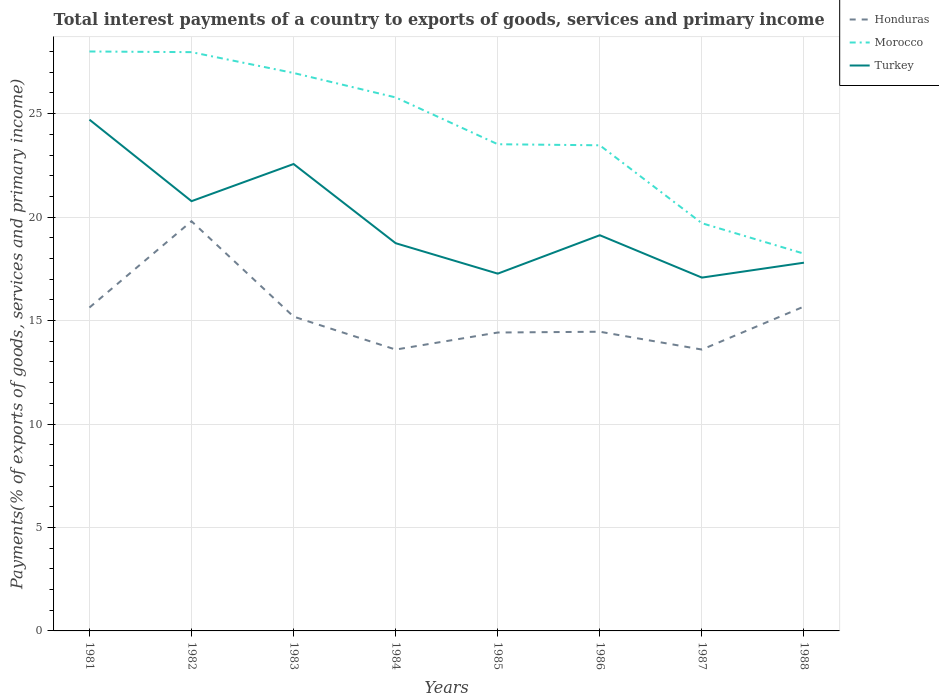How many different coloured lines are there?
Your response must be concise. 3. Does the line corresponding to Morocco intersect with the line corresponding to Honduras?
Your answer should be compact. No. Across all years, what is the maximum total interest payments in Honduras?
Provide a short and direct response. 13.6. What is the total total interest payments in Morocco in the graph?
Your response must be concise. 7.55. What is the difference between the highest and the second highest total interest payments in Turkey?
Make the answer very short. 7.63. How many years are there in the graph?
Your answer should be compact. 8. Does the graph contain grids?
Offer a terse response. Yes. Where does the legend appear in the graph?
Ensure brevity in your answer.  Top right. How many legend labels are there?
Give a very brief answer. 3. What is the title of the graph?
Offer a very short reply. Total interest payments of a country to exports of goods, services and primary income. What is the label or title of the X-axis?
Your response must be concise. Years. What is the label or title of the Y-axis?
Your response must be concise. Payments(% of exports of goods, services and primary income). What is the Payments(% of exports of goods, services and primary income) in Honduras in 1981?
Your answer should be compact. 15.63. What is the Payments(% of exports of goods, services and primary income) in Morocco in 1981?
Offer a terse response. 28. What is the Payments(% of exports of goods, services and primary income) in Turkey in 1981?
Give a very brief answer. 24.71. What is the Payments(% of exports of goods, services and primary income) of Honduras in 1982?
Provide a short and direct response. 19.8. What is the Payments(% of exports of goods, services and primary income) in Morocco in 1982?
Offer a terse response. 27.97. What is the Payments(% of exports of goods, services and primary income) in Turkey in 1982?
Keep it short and to the point. 20.77. What is the Payments(% of exports of goods, services and primary income) of Honduras in 1983?
Ensure brevity in your answer.  15.19. What is the Payments(% of exports of goods, services and primary income) of Morocco in 1983?
Your answer should be compact. 26.96. What is the Payments(% of exports of goods, services and primary income) in Turkey in 1983?
Your answer should be compact. 22.56. What is the Payments(% of exports of goods, services and primary income) in Honduras in 1984?
Provide a succinct answer. 13.6. What is the Payments(% of exports of goods, services and primary income) of Morocco in 1984?
Ensure brevity in your answer.  25.78. What is the Payments(% of exports of goods, services and primary income) of Turkey in 1984?
Your answer should be very brief. 18.74. What is the Payments(% of exports of goods, services and primary income) in Honduras in 1985?
Ensure brevity in your answer.  14.42. What is the Payments(% of exports of goods, services and primary income) of Morocco in 1985?
Keep it short and to the point. 23.52. What is the Payments(% of exports of goods, services and primary income) in Turkey in 1985?
Your answer should be compact. 17.27. What is the Payments(% of exports of goods, services and primary income) of Honduras in 1986?
Offer a very short reply. 14.46. What is the Payments(% of exports of goods, services and primary income) of Morocco in 1986?
Offer a very short reply. 23.47. What is the Payments(% of exports of goods, services and primary income) of Turkey in 1986?
Your answer should be very brief. 19.12. What is the Payments(% of exports of goods, services and primary income) in Honduras in 1987?
Make the answer very short. 13.6. What is the Payments(% of exports of goods, services and primary income) in Morocco in 1987?
Provide a succinct answer. 19.7. What is the Payments(% of exports of goods, services and primary income) in Turkey in 1987?
Keep it short and to the point. 17.08. What is the Payments(% of exports of goods, services and primary income) of Honduras in 1988?
Make the answer very short. 15.68. What is the Payments(% of exports of goods, services and primary income) of Morocco in 1988?
Make the answer very short. 18.23. What is the Payments(% of exports of goods, services and primary income) in Turkey in 1988?
Your answer should be very brief. 17.8. Across all years, what is the maximum Payments(% of exports of goods, services and primary income) of Honduras?
Ensure brevity in your answer.  19.8. Across all years, what is the maximum Payments(% of exports of goods, services and primary income) of Morocco?
Your answer should be very brief. 28. Across all years, what is the maximum Payments(% of exports of goods, services and primary income) of Turkey?
Your answer should be very brief. 24.71. Across all years, what is the minimum Payments(% of exports of goods, services and primary income) in Honduras?
Provide a succinct answer. 13.6. Across all years, what is the minimum Payments(% of exports of goods, services and primary income) in Morocco?
Your answer should be compact. 18.23. Across all years, what is the minimum Payments(% of exports of goods, services and primary income) in Turkey?
Provide a short and direct response. 17.08. What is the total Payments(% of exports of goods, services and primary income) in Honduras in the graph?
Keep it short and to the point. 122.37. What is the total Payments(% of exports of goods, services and primary income) in Morocco in the graph?
Your response must be concise. 193.65. What is the total Payments(% of exports of goods, services and primary income) in Turkey in the graph?
Offer a terse response. 158.04. What is the difference between the Payments(% of exports of goods, services and primary income) in Honduras in 1981 and that in 1982?
Offer a very short reply. -4.17. What is the difference between the Payments(% of exports of goods, services and primary income) in Morocco in 1981 and that in 1982?
Keep it short and to the point. 0.03. What is the difference between the Payments(% of exports of goods, services and primary income) of Turkey in 1981 and that in 1982?
Offer a very short reply. 3.94. What is the difference between the Payments(% of exports of goods, services and primary income) in Honduras in 1981 and that in 1983?
Offer a terse response. 0.44. What is the difference between the Payments(% of exports of goods, services and primary income) of Morocco in 1981 and that in 1983?
Keep it short and to the point. 1.04. What is the difference between the Payments(% of exports of goods, services and primary income) in Turkey in 1981 and that in 1983?
Give a very brief answer. 2.14. What is the difference between the Payments(% of exports of goods, services and primary income) of Honduras in 1981 and that in 1984?
Give a very brief answer. 2.03. What is the difference between the Payments(% of exports of goods, services and primary income) of Morocco in 1981 and that in 1984?
Offer a very short reply. 2.22. What is the difference between the Payments(% of exports of goods, services and primary income) in Turkey in 1981 and that in 1984?
Provide a succinct answer. 5.97. What is the difference between the Payments(% of exports of goods, services and primary income) of Honduras in 1981 and that in 1985?
Provide a succinct answer. 1.21. What is the difference between the Payments(% of exports of goods, services and primary income) of Morocco in 1981 and that in 1985?
Your answer should be very brief. 4.48. What is the difference between the Payments(% of exports of goods, services and primary income) of Turkey in 1981 and that in 1985?
Ensure brevity in your answer.  7.44. What is the difference between the Payments(% of exports of goods, services and primary income) of Honduras in 1981 and that in 1986?
Your response must be concise. 1.17. What is the difference between the Payments(% of exports of goods, services and primary income) in Morocco in 1981 and that in 1986?
Your response must be concise. 4.53. What is the difference between the Payments(% of exports of goods, services and primary income) in Turkey in 1981 and that in 1986?
Offer a terse response. 5.59. What is the difference between the Payments(% of exports of goods, services and primary income) in Honduras in 1981 and that in 1987?
Your answer should be very brief. 2.03. What is the difference between the Payments(% of exports of goods, services and primary income) of Morocco in 1981 and that in 1987?
Provide a short and direct response. 8.3. What is the difference between the Payments(% of exports of goods, services and primary income) in Turkey in 1981 and that in 1987?
Provide a short and direct response. 7.63. What is the difference between the Payments(% of exports of goods, services and primary income) of Honduras in 1981 and that in 1988?
Offer a very short reply. -0.05. What is the difference between the Payments(% of exports of goods, services and primary income) of Morocco in 1981 and that in 1988?
Give a very brief answer. 9.77. What is the difference between the Payments(% of exports of goods, services and primary income) in Turkey in 1981 and that in 1988?
Your response must be concise. 6.91. What is the difference between the Payments(% of exports of goods, services and primary income) in Honduras in 1982 and that in 1983?
Provide a succinct answer. 4.61. What is the difference between the Payments(% of exports of goods, services and primary income) of Morocco in 1982 and that in 1983?
Offer a terse response. 1.01. What is the difference between the Payments(% of exports of goods, services and primary income) of Turkey in 1982 and that in 1983?
Offer a terse response. -1.8. What is the difference between the Payments(% of exports of goods, services and primary income) in Honduras in 1982 and that in 1984?
Ensure brevity in your answer.  6.2. What is the difference between the Payments(% of exports of goods, services and primary income) of Morocco in 1982 and that in 1984?
Your answer should be very brief. 2.19. What is the difference between the Payments(% of exports of goods, services and primary income) in Turkey in 1982 and that in 1984?
Ensure brevity in your answer.  2.03. What is the difference between the Payments(% of exports of goods, services and primary income) of Honduras in 1982 and that in 1985?
Your answer should be very brief. 5.38. What is the difference between the Payments(% of exports of goods, services and primary income) in Morocco in 1982 and that in 1985?
Offer a terse response. 4.45. What is the difference between the Payments(% of exports of goods, services and primary income) of Turkey in 1982 and that in 1985?
Offer a terse response. 3.5. What is the difference between the Payments(% of exports of goods, services and primary income) of Honduras in 1982 and that in 1986?
Your answer should be compact. 5.34. What is the difference between the Payments(% of exports of goods, services and primary income) in Morocco in 1982 and that in 1986?
Your answer should be compact. 4.5. What is the difference between the Payments(% of exports of goods, services and primary income) of Turkey in 1982 and that in 1986?
Give a very brief answer. 1.65. What is the difference between the Payments(% of exports of goods, services and primary income) of Honduras in 1982 and that in 1987?
Offer a very short reply. 6.2. What is the difference between the Payments(% of exports of goods, services and primary income) of Morocco in 1982 and that in 1987?
Provide a short and direct response. 8.27. What is the difference between the Payments(% of exports of goods, services and primary income) of Turkey in 1982 and that in 1987?
Your answer should be compact. 3.69. What is the difference between the Payments(% of exports of goods, services and primary income) of Honduras in 1982 and that in 1988?
Your response must be concise. 4.12. What is the difference between the Payments(% of exports of goods, services and primary income) of Morocco in 1982 and that in 1988?
Your answer should be compact. 9.74. What is the difference between the Payments(% of exports of goods, services and primary income) in Turkey in 1982 and that in 1988?
Your answer should be compact. 2.97. What is the difference between the Payments(% of exports of goods, services and primary income) in Honduras in 1983 and that in 1984?
Offer a very short reply. 1.59. What is the difference between the Payments(% of exports of goods, services and primary income) in Morocco in 1983 and that in 1984?
Provide a succinct answer. 1.18. What is the difference between the Payments(% of exports of goods, services and primary income) in Turkey in 1983 and that in 1984?
Provide a short and direct response. 3.83. What is the difference between the Payments(% of exports of goods, services and primary income) in Honduras in 1983 and that in 1985?
Your answer should be very brief. 0.77. What is the difference between the Payments(% of exports of goods, services and primary income) in Morocco in 1983 and that in 1985?
Your answer should be compact. 3.44. What is the difference between the Payments(% of exports of goods, services and primary income) in Turkey in 1983 and that in 1985?
Provide a short and direct response. 5.3. What is the difference between the Payments(% of exports of goods, services and primary income) in Honduras in 1983 and that in 1986?
Provide a succinct answer. 0.73. What is the difference between the Payments(% of exports of goods, services and primary income) of Morocco in 1983 and that in 1986?
Your response must be concise. 3.49. What is the difference between the Payments(% of exports of goods, services and primary income) of Turkey in 1983 and that in 1986?
Keep it short and to the point. 3.44. What is the difference between the Payments(% of exports of goods, services and primary income) in Honduras in 1983 and that in 1987?
Offer a terse response. 1.59. What is the difference between the Payments(% of exports of goods, services and primary income) in Morocco in 1983 and that in 1987?
Your answer should be compact. 7.26. What is the difference between the Payments(% of exports of goods, services and primary income) in Turkey in 1983 and that in 1987?
Provide a short and direct response. 5.49. What is the difference between the Payments(% of exports of goods, services and primary income) in Honduras in 1983 and that in 1988?
Keep it short and to the point. -0.49. What is the difference between the Payments(% of exports of goods, services and primary income) of Morocco in 1983 and that in 1988?
Make the answer very short. 8.73. What is the difference between the Payments(% of exports of goods, services and primary income) in Turkey in 1983 and that in 1988?
Provide a succinct answer. 4.77. What is the difference between the Payments(% of exports of goods, services and primary income) in Honduras in 1984 and that in 1985?
Your answer should be very brief. -0.82. What is the difference between the Payments(% of exports of goods, services and primary income) in Morocco in 1984 and that in 1985?
Provide a short and direct response. 2.26. What is the difference between the Payments(% of exports of goods, services and primary income) of Turkey in 1984 and that in 1985?
Your response must be concise. 1.47. What is the difference between the Payments(% of exports of goods, services and primary income) in Honduras in 1984 and that in 1986?
Ensure brevity in your answer.  -0.86. What is the difference between the Payments(% of exports of goods, services and primary income) in Morocco in 1984 and that in 1986?
Your answer should be very brief. 2.31. What is the difference between the Payments(% of exports of goods, services and primary income) in Turkey in 1984 and that in 1986?
Give a very brief answer. -0.39. What is the difference between the Payments(% of exports of goods, services and primary income) of Honduras in 1984 and that in 1987?
Your answer should be very brief. -0. What is the difference between the Payments(% of exports of goods, services and primary income) of Morocco in 1984 and that in 1987?
Offer a terse response. 6.08. What is the difference between the Payments(% of exports of goods, services and primary income) in Turkey in 1984 and that in 1987?
Offer a very short reply. 1.66. What is the difference between the Payments(% of exports of goods, services and primary income) in Honduras in 1984 and that in 1988?
Offer a terse response. -2.08. What is the difference between the Payments(% of exports of goods, services and primary income) of Morocco in 1984 and that in 1988?
Your response must be concise. 7.55. What is the difference between the Payments(% of exports of goods, services and primary income) in Turkey in 1984 and that in 1988?
Offer a very short reply. 0.94. What is the difference between the Payments(% of exports of goods, services and primary income) in Honduras in 1985 and that in 1986?
Give a very brief answer. -0.04. What is the difference between the Payments(% of exports of goods, services and primary income) of Morocco in 1985 and that in 1986?
Make the answer very short. 0.05. What is the difference between the Payments(% of exports of goods, services and primary income) in Turkey in 1985 and that in 1986?
Make the answer very short. -1.86. What is the difference between the Payments(% of exports of goods, services and primary income) in Honduras in 1985 and that in 1987?
Ensure brevity in your answer.  0.82. What is the difference between the Payments(% of exports of goods, services and primary income) of Morocco in 1985 and that in 1987?
Your response must be concise. 3.82. What is the difference between the Payments(% of exports of goods, services and primary income) of Turkey in 1985 and that in 1987?
Make the answer very short. 0.19. What is the difference between the Payments(% of exports of goods, services and primary income) in Honduras in 1985 and that in 1988?
Provide a succinct answer. -1.26. What is the difference between the Payments(% of exports of goods, services and primary income) in Morocco in 1985 and that in 1988?
Provide a succinct answer. 5.29. What is the difference between the Payments(% of exports of goods, services and primary income) in Turkey in 1985 and that in 1988?
Provide a succinct answer. -0.53. What is the difference between the Payments(% of exports of goods, services and primary income) in Honduras in 1986 and that in 1987?
Your answer should be very brief. 0.86. What is the difference between the Payments(% of exports of goods, services and primary income) of Morocco in 1986 and that in 1987?
Your response must be concise. 3.77. What is the difference between the Payments(% of exports of goods, services and primary income) in Turkey in 1986 and that in 1987?
Your answer should be very brief. 2.05. What is the difference between the Payments(% of exports of goods, services and primary income) of Honduras in 1986 and that in 1988?
Your response must be concise. -1.22. What is the difference between the Payments(% of exports of goods, services and primary income) of Morocco in 1986 and that in 1988?
Provide a succinct answer. 5.24. What is the difference between the Payments(% of exports of goods, services and primary income) in Turkey in 1986 and that in 1988?
Keep it short and to the point. 1.33. What is the difference between the Payments(% of exports of goods, services and primary income) in Honduras in 1987 and that in 1988?
Offer a terse response. -2.08. What is the difference between the Payments(% of exports of goods, services and primary income) in Morocco in 1987 and that in 1988?
Your response must be concise. 1.47. What is the difference between the Payments(% of exports of goods, services and primary income) of Turkey in 1987 and that in 1988?
Keep it short and to the point. -0.72. What is the difference between the Payments(% of exports of goods, services and primary income) of Honduras in 1981 and the Payments(% of exports of goods, services and primary income) of Morocco in 1982?
Provide a succinct answer. -12.34. What is the difference between the Payments(% of exports of goods, services and primary income) of Honduras in 1981 and the Payments(% of exports of goods, services and primary income) of Turkey in 1982?
Your answer should be compact. -5.14. What is the difference between the Payments(% of exports of goods, services and primary income) of Morocco in 1981 and the Payments(% of exports of goods, services and primary income) of Turkey in 1982?
Offer a terse response. 7.23. What is the difference between the Payments(% of exports of goods, services and primary income) in Honduras in 1981 and the Payments(% of exports of goods, services and primary income) in Morocco in 1983?
Your response must be concise. -11.34. What is the difference between the Payments(% of exports of goods, services and primary income) of Honduras in 1981 and the Payments(% of exports of goods, services and primary income) of Turkey in 1983?
Keep it short and to the point. -6.94. What is the difference between the Payments(% of exports of goods, services and primary income) in Morocco in 1981 and the Payments(% of exports of goods, services and primary income) in Turkey in 1983?
Provide a short and direct response. 5.44. What is the difference between the Payments(% of exports of goods, services and primary income) of Honduras in 1981 and the Payments(% of exports of goods, services and primary income) of Morocco in 1984?
Keep it short and to the point. -10.15. What is the difference between the Payments(% of exports of goods, services and primary income) of Honduras in 1981 and the Payments(% of exports of goods, services and primary income) of Turkey in 1984?
Offer a very short reply. -3.11. What is the difference between the Payments(% of exports of goods, services and primary income) in Morocco in 1981 and the Payments(% of exports of goods, services and primary income) in Turkey in 1984?
Offer a terse response. 9.27. What is the difference between the Payments(% of exports of goods, services and primary income) in Honduras in 1981 and the Payments(% of exports of goods, services and primary income) in Morocco in 1985?
Make the answer very short. -7.89. What is the difference between the Payments(% of exports of goods, services and primary income) of Honduras in 1981 and the Payments(% of exports of goods, services and primary income) of Turkey in 1985?
Your answer should be compact. -1.64. What is the difference between the Payments(% of exports of goods, services and primary income) of Morocco in 1981 and the Payments(% of exports of goods, services and primary income) of Turkey in 1985?
Provide a short and direct response. 10.74. What is the difference between the Payments(% of exports of goods, services and primary income) in Honduras in 1981 and the Payments(% of exports of goods, services and primary income) in Morocco in 1986?
Provide a short and direct response. -7.84. What is the difference between the Payments(% of exports of goods, services and primary income) in Honduras in 1981 and the Payments(% of exports of goods, services and primary income) in Turkey in 1986?
Ensure brevity in your answer.  -3.5. What is the difference between the Payments(% of exports of goods, services and primary income) of Morocco in 1981 and the Payments(% of exports of goods, services and primary income) of Turkey in 1986?
Make the answer very short. 8.88. What is the difference between the Payments(% of exports of goods, services and primary income) in Honduras in 1981 and the Payments(% of exports of goods, services and primary income) in Morocco in 1987?
Your answer should be very brief. -4.08. What is the difference between the Payments(% of exports of goods, services and primary income) in Honduras in 1981 and the Payments(% of exports of goods, services and primary income) in Turkey in 1987?
Offer a terse response. -1.45. What is the difference between the Payments(% of exports of goods, services and primary income) in Morocco in 1981 and the Payments(% of exports of goods, services and primary income) in Turkey in 1987?
Your answer should be very brief. 10.93. What is the difference between the Payments(% of exports of goods, services and primary income) of Honduras in 1981 and the Payments(% of exports of goods, services and primary income) of Morocco in 1988?
Your answer should be compact. -2.6. What is the difference between the Payments(% of exports of goods, services and primary income) in Honduras in 1981 and the Payments(% of exports of goods, services and primary income) in Turkey in 1988?
Keep it short and to the point. -2.17. What is the difference between the Payments(% of exports of goods, services and primary income) in Morocco in 1981 and the Payments(% of exports of goods, services and primary income) in Turkey in 1988?
Your answer should be compact. 10.21. What is the difference between the Payments(% of exports of goods, services and primary income) of Honduras in 1982 and the Payments(% of exports of goods, services and primary income) of Morocco in 1983?
Provide a short and direct response. -7.16. What is the difference between the Payments(% of exports of goods, services and primary income) of Honduras in 1982 and the Payments(% of exports of goods, services and primary income) of Turkey in 1983?
Your answer should be compact. -2.77. What is the difference between the Payments(% of exports of goods, services and primary income) of Morocco in 1982 and the Payments(% of exports of goods, services and primary income) of Turkey in 1983?
Give a very brief answer. 5.41. What is the difference between the Payments(% of exports of goods, services and primary income) in Honduras in 1982 and the Payments(% of exports of goods, services and primary income) in Morocco in 1984?
Keep it short and to the point. -5.98. What is the difference between the Payments(% of exports of goods, services and primary income) of Honduras in 1982 and the Payments(% of exports of goods, services and primary income) of Turkey in 1984?
Your answer should be compact. 1.06. What is the difference between the Payments(% of exports of goods, services and primary income) of Morocco in 1982 and the Payments(% of exports of goods, services and primary income) of Turkey in 1984?
Make the answer very short. 9.23. What is the difference between the Payments(% of exports of goods, services and primary income) in Honduras in 1982 and the Payments(% of exports of goods, services and primary income) in Morocco in 1985?
Offer a very short reply. -3.72. What is the difference between the Payments(% of exports of goods, services and primary income) of Honduras in 1982 and the Payments(% of exports of goods, services and primary income) of Turkey in 1985?
Keep it short and to the point. 2.53. What is the difference between the Payments(% of exports of goods, services and primary income) of Morocco in 1982 and the Payments(% of exports of goods, services and primary income) of Turkey in 1985?
Give a very brief answer. 10.7. What is the difference between the Payments(% of exports of goods, services and primary income) of Honduras in 1982 and the Payments(% of exports of goods, services and primary income) of Morocco in 1986?
Give a very brief answer. -3.67. What is the difference between the Payments(% of exports of goods, services and primary income) of Honduras in 1982 and the Payments(% of exports of goods, services and primary income) of Turkey in 1986?
Provide a short and direct response. 0.68. What is the difference between the Payments(% of exports of goods, services and primary income) of Morocco in 1982 and the Payments(% of exports of goods, services and primary income) of Turkey in 1986?
Keep it short and to the point. 8.85. What is the difference between the Payments(% of exports of goods, services and primary income) in Honduras in 1982 and the Payments(% of exports of goods, services and primary income) in Morocco in 1987?
Your answer should be very brief. 0.1. What is the difference between the Payments(% of exports of goods, services and primary income) of Honduras in 1982 and the Payments(% of exports of goods, services and primary income) of Turkey in 1987?
Offer a terse response. 2.72. What is the difference between the Payments(% of exports of goods, services and primary income) in Morocco in 1982 and the Payments(% of exports of goods, services and primary income) in Turkey in 1987?
Your answer should be very brief. 10.9. What is the difference between the Payments(% of exports of goods, services and primary income) in Honduras in 1982 and the Payments(% of exports of goods, services and primary income) in Morocco in 1988?
Your response must be concise. 1.57. What is the difference between the Payments(% of exports of goods, services and primary income) in Honduras in 1982 and the Payments(% of exports of goods, services and primary income) in Turkey in 1988?
Your response must be concise. 2. What is the difference between the Payments(% of exports of goods, services and primary income) of Morocco in 1982 and the Payments(% of exports of goods, services and primary income) of Turkey in 1988?
Ensure brevity in your answer.  10.18. What is the difference between the Payments(% of exports of goods, services and primary income) in Honduras in 1983 and the Payments(% of exports of goods, services and primary income) in Morocco in 1984?
Provide a succinct answer. -10.59. What is the difference between the Payments(% of exports of goods, services and primary income) of Honduras in 1983 and the Payments(% of exports of goods, services and primary income) of Turkey in 1984?
Your answer should be very brief. -3.55. What is the difference between the Payments(% of exports of goods, services and primary income) in Morocco in 1983 and the Payments(% of exports of goods, services and primary income) in Turkey in 1984?
Provide a short and direct response. 8.23. What is the difference between the Payments(% of exports of goods, services and primary income) of Honduras in 1983 and the Payments(% of exports of goods, services and primary income) of Morocco in 1985?
Make the answer very short. -8.33. What is the difference between the Payments(% of exports of goods, services and primary income) of Honduras in 1983 and the Payments(% of exports of goods, services and primary income) of Turkey in 1985?
Make the answer very short. -2.08. What is the difference between the Payments(% of exports of goods, services and primary income) of Morocco in 1983 and the Payments(% of exports of goods, services and primary income) of Turkey in 1985?
Provide a succinct answer. 9.7. What is the difference between the Payments(% of exports of goods, services and primary income) in Honduras in 1983 and the Payments(% of exports of goods, services and primary income) in Morocco in 1986?
Provide a short and direct response. -8.28. What is the difference between the Payments(% of exports of goods, services and primary income) of Honduras in 1983 and the Payments(% of exports of goods, services and primary income) of Turkey in 1986?
Offer a very short reply. -3.93. What is the difference between the Payments(% of exports of goods, services and primary income) of Morocco in 1983 and the Payments(% of exports of goods, services and primary income) of Turkey in 1986?
Provide a short and direct response. 7.84. What is the difference between the Payments(% of exports of goods, services and primary income) of Honduras in 1983 and the Payments(% of exports of goods, services and primary income) of Morocco in 1987?
Keep it short and to the point. -4.51. What is the difference between the Payments(% of exports of goods, services and primary income) of Honduras in 1983 and the Payments(% of exports of goods, services and primary income) of Turkey in 1987?
Give a very brief answer. -1.89. What is the difference between the Payments(% of exports of goods, services and primary income) of Morocco in 1983 and the Payments(% of exports of goods, services and primary income) of Turkey in 1987?
Provide a succinct answer. 9.89. What is the difference between the Payments(% of exports of goods, services and primary income) in Honduras in 1983 and the Payments(% of exports of goods, services and primary income) in Morocco in 1988?
Keep it short and to the point. -3.04. What is the difference between the Payments(% of exports of goods, services and primary income) of Honduras in 1983 and the Payments(% of exports of goods, services and primary income) of Turkey in 1988?
Make the answer very short. -2.61. What is the difference between the Payments(% of exports of goods, services and primary income) in Morocco in 1983 and the Payments(% of exports of goods, services and primary income) in Turkey in 1988?
Offer a terse response. 9.17. What is the difference between the Payments(% of exports of goods, services and primary income) in Honduras in 1984 and the Payments(% of exports of goods, services and primary income) in Morocco in 1985?
Provide a short and direct response. -9.92. What is the difference between the Payments(% of exports of goods, services and primary income) of Honduras in 1984 and the Payments(% of exports of goods, services and primary income) of Turkey in 1985?
Keep it short and to the point. -3.67. What is the difference between the Payments(% of exports of goods, services and primary income) of Morocco in 1984 and the Payments(% of exports of goods, services and primary income) of Turkey in 1985?
Make the answer very short. 8.52. What is the difference between the Payments(% of exports of goods, services and primary income) in Honduras in 1984 and the Payments(% of exports of goods, services and primary income) in Morocco in 1986?
Keep it short and to the point. -9.87. What is the difference between the Payments(% of exports of goods, services and primary income) of Honduras in 1984 and the Payments(% of exports of goods, services and primary income) of Turkey in 1986?
Keep it short and to the point. -5.53. What is the difference between the Payments(% of exports of goods, services and primary income) in Morocco in 1984 and the Payments(% of exports of goods, services and primary income) in Turkey in 1986?
Make the answer very short. 6.66. What is the difference between the Payments(% of exports of goods, services and primary income) of Honduras in 1984 and the Payments(% of exports of goods, services and primary income) of Morocco in 1987?
Your answer should be very brief. -6.11. What is the difference between the Payments(% of exports of goods, services and primary income) of Honduras in 1984 and the Payments(% of exports of goods, services and primary income) of Turkey in 1987?
Offer a terse response. -3.48. What is the difference between the Payments(% of exports of goods, services and primary income) in Morocco in 1984 and the Payments(% of exports of goods, services and primary income) in Turkey in 1987?
Give a very brief answer. 8.71. What is the difference between the Payments(% of exports of goods, services and primary income) in Honduras in 1984 and the Payments(% of exports of goods, services and primary income) in Morocco in 1988?
Keep it short and to the point. -4.63. What is the difference between the Payments(% of exports of goods, services and primary income) of Honduras in 1984 and the Payments(% of exports of goods, services and primary income) of Turkey in 1988?
Ensure brevity in your answer.  -4.2. What is the difference between the Payments(% of exports of goods, services and primary income) of Morocco in 1984 and the Payments(% of exports of goods, services and primary income) of Turkey in 1988?
Offer a very short reply. 7.99. What is the difference between the Payments(% of exports of goods, services and primary income) in Honduras in 1985 and the Payments(% of exports of goods, services and primary income) in Morocco in 1986?
Your response must be concise. -9.05. What is the difference between the Payments(% of exports of goods, services and primary income) in Honduras in 1985 and the Payments(% of exports of goods, services and primary income) in Turkey in 1986?
Provide a short and direct response. -4.7. What is the difference between the Payments(% of exports of goods, services and primary income) of Morocco in 1985 and the Payments(% of exports of goods, services and primary income) of Turkey in 1986?
Give a very brief answer. 4.4. What is the difference between the Payments(% of exports of goods, services and primary income) in Honduras in 1985 and the Payments(% of exports of goods, services and primary income) in Morocco in 1987?
Your answer should be very brief. -5.28. What is the difference between the Payments(% of exports of goods, services and primary income) in Honduras in 1985 and the Payments(% of exports of goods, services and primary income) in Turkey in 1987?
Give a very brief answer. -2.65. What is the difference between the Payments(% of exports of goods, services and primary income) in Morocco in 1985 and the Payments(% of exports of goods, services and primary income) in Turkey in 1987?
Your answer should be compact. 6.45. What is the difference between the Payments(% of exports of goods, services and primary income) in Honduras in 1985 and the Payments(% of exports of goods, services and primary income) in Morocco in 1988?
Make the answer very short. -3.81. What is the difference between the Payments(% of exports of goods, services and primary income) of Honduras in 1985 and the Payments(% of exports of goods, services and primary income) of Turkey in 1988?
Provide a succinct answer. -3.37. What is the difference between the Payments(% of exports of goods, services and primary income) of Morocco in 1985 and the Payments(% of exports of goods, services and primary income) of Turkey in 1988?
Offer a terse response. 5.72. What is the difference between the Payments(% of exports of goods, services and primary income) of Honduras in 1986 and the Payments(% of exports of goods, services and primary income) of Morocco in 1987?
Keep it short and to the point. -5.24. What is the difference between the Payments(% of exports of goods, services and primary income) of Honduras in 1986 and the Payments(% of exports of goods, services and primary income) of Turkey in 1987?
Offer a very short reply. -2.62. What is the difference between the Payments(% of exports of goods, services and primary income) in Morocco in 1986 and the Payments(% of exports of goods, services and primary income) in Turkey in 1987?
Provide a short and direct response. 6.39. What is the difference between the Payments(% of exports of goods, services and primary income) of Honduras in 1986 and the Payments(% of exports of goods, services and primary income) of Morocco in 1988?
Ensure brevity in your answer.  -3.77. What is the difference between the Payments(% of exports of goods, services and primary income) in Honduras in 1986 and the Payments(% of exports of goods, services and primary income) in Turkey in 1988?
Ensure brevity in your answer.  -3.34. What is the difference between the Payments(% of exports of goods, services and primary income) in Morocco in 1986 and the Payments(% of exports of goods, services and primary income) in Turkey in 1988?
Make the answer very short. 5.67. What is the difference between the Payments(% of exports of goods, services and primary income) in Honduras in 1987 and the Payments(% of exports of goods, services and primary income) in Morocco in 1988?
Provide a succinct answer. -4.63. What is the difference between the Payments(% of exports of goods, services and primary income) of Honduras in 1987 and the Payments(% of exports of goods, services and primary income) of Turkey in 1988?
Your answer should be very brief. -4.2. What is the difference between the Payments(% of exports of goods, services and primary income) of Morocco in 1987 and the Payments(% of exports of goods, services and primary income) of Turkey in 1988?
Ensure brevity in your answer.  1.91. What is the average Payments(% of exports of goods, services and primary income) of Honduras per year?
Ensure brevity in your answer.  15.3. What is the average Payments(% of exports of goods, services and primary income) in Morocco per year?
Keep it short and to the point. 24.21. What is the average Payments(% of exports of goods, services and primary income) in Turkey per year?
Your response must be concise. 19.76. In the year 1981, what is the difference between the Payments(% of exports of goods, services and primary income) of Honduras and Payments(% of exports of goods, services and primary income) of Morocco?
Provide a short and direct response. -12.38. In the year 1981, what is the difference between the Payments(% of exports of goods, services and primary income) of Honduras and Payments(% of exports of goods, services and primary income) of Turkey?
Provide a short and direct response. -9.08. In the year 1981, what is the difference between the Payments(% of exports of goods, services and primary income) of Morocco and Payments(% of exports of goods, services and primary income) of Turkey?
Offer a very short reply. 3.29. In the year 1982, what is the difference between the Payments(% of exports of goods, services and primary income) of Honduras and Payments(% of exports of goods, services and primary income) of Morocco?
Offer a very short reply. -8.17. In the year 1982, what is the difference between the Payments(% of exports of goods, services and primary income) in Honduras and Payments(% of exports of goods, services and primary income) in Turkey?
Give a very brief answer. -0.97. In the year 1982, what is the difference between the Payments(% of exports of goods, services and primary income) of Morocco and Payments(% of exports of goods, services and primary income) of Turkey?
Your response must be concise. 7.2. In the year 1983, what is the difference between the Payments(% of exports of goods, services and primary income) of Honduras and Payments(% of exports of goods, services and primary income) of Morocco?
Your answer should be compact. -11.77. In the year 1983, what is the difference between the Payments(% of exports of goods, services and primary income) of Honduras and Payments(% of exports of goods, services and primary income) of Turkey?
Provide a succinct answer. -7.38. In the year 1983, what is the difference between the Payments(% of exports of goods, services and primary income) of Morocco and Payments(% of exports of goods, services and primary income) of Turkey?
Provide a short and direct response. 4.4. In the year 1984, what is the difference between the Payments(% of exports of goods, services and primary income) of Honduras and Payments(% of exports of goods, services and primary income) of Morocco?
Your answer should be very brief. -12.19. In the year 1984, what is the difference between the Payments(% of exports of goods, services and primary income) of Honduras and Payments(% of exports of goods, services and primary income) of Turkey?
Your answer should be very brief. -5.14. In the year 1984, what is the difference between the Payments(% of exports of goods, services and primary income) of Morocco and Payments(% of exports of goods, services and primary income) of Turkey?
Provide a succinct answer. 7.05. In the year 1985, what is the difference between the Payments(% of exports of goods, services and primary income) of Honduras and Payments(% of exports of goods, services and primary income) of Morocco?
Your response must be concise. -9.1. In the year 1985, what is the difference between the Payments(% of exports of goods, services and primary income) of Honduras and Payments(% of exports of goods, services and primary income) of Turkey?
Your response must be concise. -2.85. In the year 1985, what is the difference between the Payments(% of exports of goods, services and primary income) of Morocco and Payments(% of exports of goods, services and primary income) of Turkey?
Keep it short and to the point. 6.25. In the year 1986, what is the difference between the Payments(% of exports of goods, services and primary income) in Honduras and Payments(% of exports of goods, services and primary income) in Morocco?
Ensure brevity in your answer.  -9.01. In the year 1986, what is the difference between the Payments(% of exports of goods, services and primary income) in Honduras and Payments(% of exports of goods, services and primary income) in Turkey?
Give a very brief answer. -4.66. In the year 1986, what is the difference between the Payments(% of exports of goods, services and primary income) of Morocco and Payments(% of exports of goods, services and primary income) of Turkey?
Your answer should be very brief. 4.35. In the year 1987, what is the difference between the Payments(% of exports of goods, services and primary income) of Honduras and Payments(% of exports of goods, services and primary income) of Morocco?
Give a very brief answer. -6.11. In the year 1987, what is the difference between the Payments(% of exports of goods, services and primary income) of Honduras and Payments(% of exports of goods, services and primary income) of Turkey?
Provide a succinct answer. -3.48. In the year 1987, what is the difference between the Payments(% of exports of goods, services and primary income) of Morocco and Payments(% of exports of goods, services and primary income) of Turkey?
Give a very brief answer. 2.63. In the year 1988, what is the difference between the Payments(% of exports of goods, services and primary income) of Honduras and Payments(% of exports of goods, services and primary income) of Morocco?
Your answer should be very brief. -2.56. In the year 1988, what is the difference between the Payments(% of exports of goods, services and primary income) of Honduras and Payments(% of exports of goods, services and primary income) of Turkey?
Offer a terse response. -2.12. In the year 1988, what is the difference between the Payments(% of exports of goods, services and primary income) of Morocco and Payments(% of exports of goods, services and primary income) of Turkey?
Your answer should be compact. 0.44. What is the ratio of the Payments(% of exports of goods, services and primary income) in Honduras in 1981 to that in 1982?
Your answer should be very brief. 0.79. What is the ratio of the Payments(% of exports of goods, services and primary income) in Morocco in 1981 to that in 1982?
Keep it short and to the point. 1. What is the ratio of the Payments(% of exports of goods, services and primary income) of Turkey in 1981 to that in 1982?
Give a very brief answer. 1.19. What is the ratio of the Payments(% of exports of goods, services and primary income) in Honduras in 1981 to that in 1983?
Your answer should be compact. 1.03. What is the ratio of the Payments(% of exports of goods, services and primary income) in Morocco in 1981 to that in 1983?
Give a very brief answer. 1.04. What is the ratio of the Payments(% of exports of goods, services and primary income) in Turkey in 1981 to that in 1983?
Make the answer very short. 1.09. What is the ratio of the Payments(% of exports of goods, services and primary income) of Honduras in 1981 to that in 1984?
Ensure brevity in your answer.  1.15. What is the ratio of the Payments(% of exports of goods, services and primary income) in Morocco in 1981 to that in 1984?
Offer a very short reply. 1.09. What is the ratio of the Payments(% of exports of goods, services and primary income) of Turkey in 1981 to that in 1984?
Give a very brief answer. 1.32. What is the ratio of the Payments(% of exports of goods, services and primary income) in Honduras in 1981 to that in 1985?
Provide a short and direct response. 1.08. What is the ratio of the Payments(% of exports of goods, services and primary income) in Morocco in 1981 to that in 1985?
Make the answer very short. 1.19. What is the ratio of the Payments(% of exports of goods, services and primary income) of Turkey in 1981 to that in 1985?
Give a very brief answer. 1.43. What is the ratio of the Payments(% of exports of goods, services and primary income) in Honduras in 1981 to that in 1986?
Offer a very short reply. 1.08. What is the ratio of the Payments(% of exports of goods, services and primary income) of Morocco in 1981 to that in 1986?
Your response must be concise. 1.19. What is the ratio of the Payments(% of exports of goods, services and primary income) of Turkey in 1981 to that in 1986?
Ensure brevity in your answer.  1.29. What is the ratio of the Payments(% of exports of goods, services and primary income) of Honduras in 1981 to that in 1987?
Provide a short and direct response. 1.15. What is the ratio of the Payments(% of exports of goods, services and primary income) of Morocco in 1981 to that in 1987?
Your answer should be very brief. 1.42. What is the ratio of the Payments(% of exports of goods, services and primary income) of Turkey in 1981 to that in 1987?
Your answer should be very brief. 1.45. What is the ratio of the Payments(% of exports of goods, services and primary income) of Morocco in 1981 to that in 1988?
Your answer should be compact. 1.54. What is the ratio of the Payments(% of exports of goods, services and primary income) of Turkey in 1981 to that in 1988?
Ensure brevity in your answer.  1.39. What is the ratio of the Payments(% of exports of goods, services and primary income) of Honduras in 1982 to that in 1983?
Ensure brevity in your answer.  1.3. What is the ratio of the Payments(% of exports of goods, services and primary income) of Morocco in 1982 to that in 1983?
Ensure brevity in your answer.  1.04. What is the ratio of the Payments(% of exports of goods, services and primary income) in Turkey in 1982 to that in 1983?
Provide a succinct answer. 0.92. What is the ratio of the Payments(% of exports of goods, services and primary income) in Honduras in 1982 to that in 1984?
Offer a terse response. 1.46. What is the ratio of the Payments(% of exports of goods, services and primary income) of Morocco in 1982 to that in 1984?
Offer a very short reply. 1.08. What is the ratio of the Payments(% of exports of goods, services and primary income) of Turkey in 1982 to that in 1984?
Offer a terse response. 1.11. What is the ratio of the Payments(% of exports of goods, services and primary income) of Honduras in 1982 to that in 1985?
Your response must be concise. 1.37. What is the ratio of the Payments(% of exports of goods, services and primary income) in Morocco in 1982 to that in 1985?
Offer a very short reply. 1.19. What is the ratio of the Payments(% of exports of goods, services and primary income) in Turkey in 1982 to that in 1985?
Your answer should be very brief. 1.2. What is the ratio of the Payments(% of exports of goods, services and primary income) in Honduras in 1982 to that in 1986?
Keep it short and to the point. 1.37. What is the ratio of the Payments(% of exports of goods, services and primary income) of Morocco in 1982 to that in 1986?
Your answer should be compact. 1.19. What is the ratio of the Payments(% of exports of goods, services and primary income) in Turkey in 1982 to that in 1986?
Provide a succinct answer. 1.09. What is the ratio of the Payments(% of exports of goods, services and primary income) in Honduras in 1982 to that in 1987?
Make the answer very short. 1.46. What is the ratio of the Payments(% of exports of goods, services and primary income) of Morocco in 1982 to that in 1987?
Ensure brevity in your answer.  1.42. What is the ratio of the Payments(% of exports of goods, services and primary income) in Turkey in 1982 to that in 1987?
Your answer should be very brief. 1.22. What is the ratio of the Payments(% of exports of goods, services and primary income) of Honduras in 1982 to that in 1988?
Keep it short and to the point. 1.26. What is the ratio of the Payments(% of exports of goods, services and primary income) in Morocco in 1982 to that in 1988?
Offer a terse response. 1.53. What is the ratio of the Payments(% of exports of goods, services and primary income) of Turkey in 1982 to that in 1988?
Offer a very short reply. 1.17. What is the ratio of the Payments(% of exports of goods, services and primary income) of Honduras in 1983 to that in 1984?
Give a very brief answer. 1.12. What is the ratio of the Payments(% of exports of goods, services and primary income) of Morocco in 1983 to that in 1984?
Give a very brief answer. 1.05. What is the ratio of the Payments(% of exports of goods, services and primary income) in Turkey in 1983 to that in 1984?
Provide a succinct answer. 1.2. What is the ratio of the Payments(% of exports of goods, services and primary income) of Honduras in 1983 to that in 1985?
Offer a terse response. 1.05. What is the ratio of the Payments(% of exports of goods, services and primary income) in Morocco in 1983 to that in 1985?
Your answer should be compact. 1.15. What is the ratio of the Payments(% of exports of goods, services and primary income) of Turkey in 1983 to that in 1985?
Offer a terse response. 1.31. What is the ratio of the Payments(% of exports of goods, services and primary income) of Honduras in 1983 to that in 1986?
Offer a very short reply. 1.05. What is the ratio of the Payments(% of exports of goods, services and primary income) in Morocco in 1983 to that in 1986?
Your answer should be very brief. 1.15. What is the ratio of the Payments(% of exports of goods, services and primary income) of Turkey in 1983 to that in 1986?
Offer a terse response. 1.18. What is the ratio of the Payments(% of exports of goods, services and primary income) of Honduras in 1983 to that in 1987?
Offer a very short reply. 1.12. What is the ratio of the Payments(% of exports of goods, services and primary income) of Morocco in 1983 to that in 1987?
Give a very brief answer. 1.37. What is the ratio of the Payments(% of exports of goods, services and primary income) in Turkey in 1983 to that in 1987?
Provide a short and direct response. 1.32. What is the ratio of the Payments(% of exports of goods, services and primary income) in Honduras in 1983 to that in 1988?
Ensure brevity in your answer.  0.97. What is the ratio of the Payments(% of exports of goods, services and primary income) in Morocco in 1983 to that in 1988?
Provide a succinct answer. 1.48. What is the ratio of the Payments(% of exports of goods, services and primary income) in Turkey in 1983 to that in 1988?
Give a very brief answer. 1.27. What is the ratio of the Payments(% of exports of goods, services and primary income) in Honduras in 1984 to that in 1985?
Give a very brief answer. 0.94. What is the ratio of the Payments(% of exports of goods, services and primary income) in Morocco in 1984 to that in 1985?
Keep it short and to the point. 1.1. What is the ratio of the Payments(% of exports of goods, services and primary income) of Turkey in 1984 to that in 1985?
Your answer should be very brief. 1.09. What is the ratio of the Payments(% of exports of goods, services and primary income) in Honduras in 1984 to that in 1986?
Provide a succinct answer. 0.94. What is the ratio of the Payments(% of exports of goods, services and primary income) of Morocco in 1984 to that in 1986?
Your answer should be compact. 1.1. What is the ratio of the Payments(% of exports of goods, services and primary income) in Turkey in 1984 to that in 1986?
Your answer should be very brief. 0.98. What is the ratio of the Payments(% of exports of goods, services and primary income) of Morocco in 1984 to that in 1987?
Give a very brief answer. 1.31. What is the ratio of the Payments(% of exports of goods, services and primary income) of Turkey in 1984 to that in 1987?
Provide a succinct answer. 1.1. What is the ratio of the Payments(% of exports of goods, services and primary income) of Honduras in 1984 to that in 1988?
Provide a short and direct response. 0.87. What is the ratio of the Payments(% of exports of goods, services and primary income) of Morocco in 1984 to that in 1988?
Your answer should be compact. 1.41. What is the ratio of the Payments(% of exports of goods, services and primary income) of Turkey in 1984 to that in 1988?
Your answer should be compact. 1.05. What is the ratio of the Payments(% of exports of goods, services and primary income) of Turkey in 1985 to that in 1986?
Provide a short and direct response. 0.9. What is the ratio of the Payments(% of exports of goods, services and primary income) in Honduras in 1985 to that in 1987?
Keep it short and to the point. 1.06. What is the ratio of the Payments(% of exports of goods, services and primary income) in Morocco in 1985 to that in 1987?
Make the answer very short. 1.19. What is the ratio of the Payments(% of exports of goods, services and primary income) of Turkey in 1985 to that in 1987?
Your answer should be very brief. 1.01. What is the ratio of the Payments(% of exports of goods, services and primary income) in Honduras in 1985 to that in 1988?
Make the answer very short. 0.92. What is the ratio of the Payments(% of exports of goods, services and primary income) in Morocco in 1985 to that in 1988?
Offer a very short reply. 1.29. What is the ratio of the Payments(% of exports of goods, services and primary income) of Turkey in 1985 to that in 1988?
Give a very brief answer. 0.97. What is the ratio of the Payments(% of exports of goods, services and primary income) of Honduras in 1986 to that in 1987?
Keep it short and to the point. 1.06. What is the ratio of the Payments(% of exports of goods, services and primary income) in Morocco in 1986 to that in 1987?
Ensure brevity in your answer.  1.19. What is the ratio of the Payments(% of exports of goods, services and primary income) in Turkey in 1986 to that in 1987?
Provide a succinct answer. 1.12. What is the ratio of the Payments(% of exports of goods, services and primary income) in Honduras in 1986 to that in 1988?
Offer a very short reply. 0.92. What is the ratio of the Payments(% of exports of goods, services and primary income) in Morocco in 1986 to that in 1988?
Your answer should be very brief. 1.29. What is the ratio of the Payments(% of exports of goods, services and primary income) of Turkey in 1986 to that in 1988?
Offer a very short reply. 1.07. What is the ratio of the Payments(% of exports of goods, services and primary income) of Honduras in 1987 to that in 1988?
Keep it short and to the point. 0.87. What is the ratio of the Payments(% of exports of goods, services and primary income) in Morocco in 1987 to that in 1988?
Give a very brief answer. 1.08. What is the ratio of the Payments(% of exports of goods, services and primary income) of Turkey in 1987 to that in 1988?
Keep it short and to the point. 0.96. What is the difference between the highest and the second highest Payments(% of exports of goods, services and primary income) in Honduras?
Give a very brief answer. 4.12. What is the difference between the highest and the second highest Payments(% of exports of goods, services and primary income) in Morocco?
Offer a very short reply. 0.03. What is the difference between the highest and the second highest Payments(% of exports of goods, services and primary income) in Turkey?
Offer a terse response. 2.14. What is the difference between the highest and the lowest Payments(% of exports of goods, services and primary income) of Honduras?
Ensure brevity in your answer.  6.2. What is the difference between the highest and the lowest Payments(% of exports of goods, services and primary income) in Morocco?
Your response must be concise. 9.77. What is the difference between the highest and the lowest Payments(% of exports of goods, services and primary income) in Turkey?
Offer a very short reply. 7.63. 